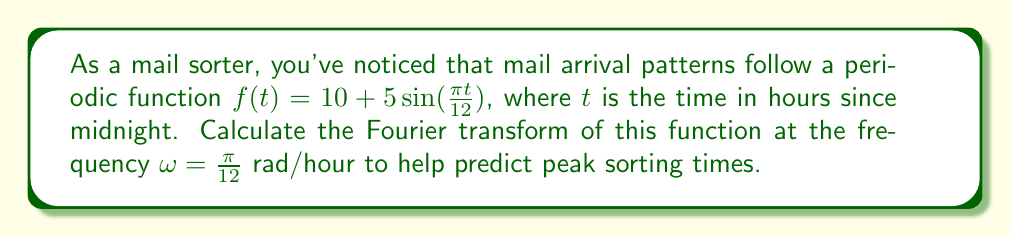Can you solve this math problem? To compute the Fourier transform of the given function at $\omega = \frac{\pi}{12}$, we follow these steps:

1) The Fourier transform is defined as:
   $$F(\omega) = \int_{-\infty}^{\infty} f(t) e^{-i\omega t} dt$$

2) Our function is:
   $$f(t) = 10 + 5\sin(\frac{\pi t}{12})$$

3) Substituting into the Fourier transform equation:
   $$F(\frac{\pi}{12}) = \int_{-\infty}^{\infty} (10 + 5\sin(\frac{\pi t}{12})) e^{-i\frac{\pi t}{12}} dt$$

4) We can split this into two integrals:
   $$F(\frac{\pi}{12}) = 10\int_{-\infty}^{\infty} e^{-i\frac{\pi t}{12}} dt + 5\int_{-\infty}^{\infty} \sin(\frac{\pi t}{12}) e^{-i\frac{\pi t}{12}} dt$$

5) The first integral is the Fourier transform of a constant, which gives a delta function:
   $$10\int_{-\infty}^{\infty} e^{-i\frac{\pi t}{12}} dt = 20\pi\delta(\frac{\pi}{12})$$

6) For the second integral, we can use Euler's formula: $\sin(x) = \frac{e^{ix} - e^{-ix}}{2i}$
   $$5\int_{-\infty}^{\infty} \sin(\frac{\pi t}{12}) e^{-i\frac{\pi t}{12}} dt = \frac{5}{2i}\int_{-\infty}^{\infty} (e^{i\frac{\pi t}{12}} - e^{-i\frac{\pi t}{12}}) e^{-i\frac{\pi t}{12}} dt$$

7) This simplifies to:
   $$\frac{5}{2i}\int_{-\infty}^{\infty} (1 - e^{-i\frac{\pi t}{6}}) dt$$

8) The integral of 1 gives another delta function, and the integral of $e^{-i\frac{\pi t}{6}}$ is zero except at $\omega = \frac{\pi}{6}$:
   $$\frac{5}{2i}(2\pi\delta(0) - 2\pi\delta(\frac{\pi}{6}))$$

9) Combining the results:
   $$F(\frac{\pi}{12}) = 20\pi\delta(\frac{\pi}{12}) + \frac{5\pi}{i}(\delta(0) - \delta(\frac{\pi}{6}))$$
Answer: $20\pi\delta(\frac{\pi}{12}) + \frac{5\pi}{i}(\delta(0) - \delta(\frac{\pi}{6}))$ 